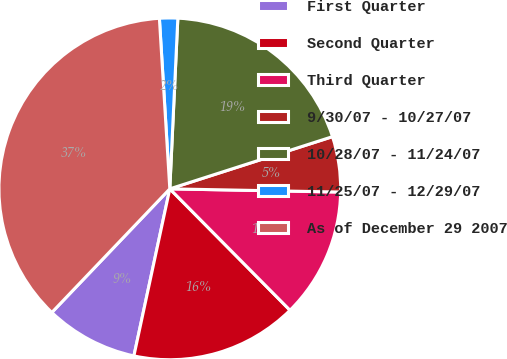Convert chart. <chart><loc_0><loc_0><loc_500><loc_500><pie_chart><fcel>First Quarter<fcel>Second Quarter<fcel>Third Quarter<fcel>9/30/07 - 10/27/07<fcel>10/28/07 - 11/24/07<fcel>11/25/07 - 12/29/07<fcel>As of December 29 2007<nl><fcel>8.76%<fcel>15.79%<fcel>12.28%<fcel>5.24%<fcel>19.31%<fcel>1.72%<fcel>36.9%<nl></chart> 